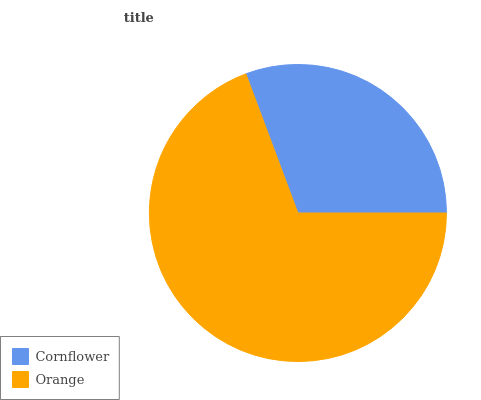Is Cornflower the minimum?
Answer yes or no. Yes. Is Orange the maximum?
Answer yes or no. Yes. Is Orange the minimum?
Answer yes or no. No. Is Orange greater than Cornflower?
Answer yes or no. Yes. Is Cornflower less than Orange?
Answer yes or no. Yes. Is Cornflower greater than Orange?
Answer yes or no. No. Is Orange less than Cornflower?
Answer yes or no. No. Is Orange the high median?
Answer yes or no. Yes. Is Cornflower the low median?
Answer yes or no. Yes. Is Cornflower the high median?
Answer yes or no. No. Is Orange the low median?
Answer yes or no. No. 